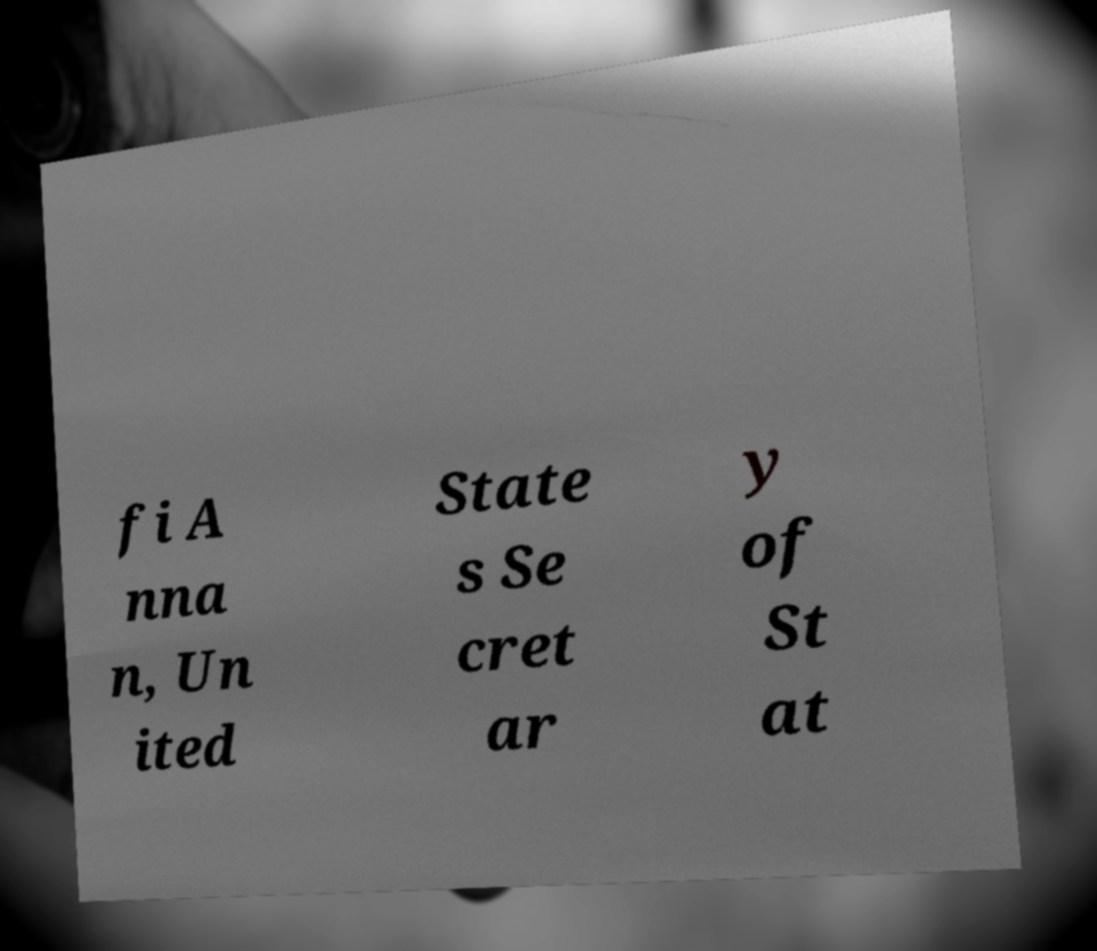Please identify and transcribe the text found in this image. fi A nna n, Un ited State s Se cret ar y of St at 